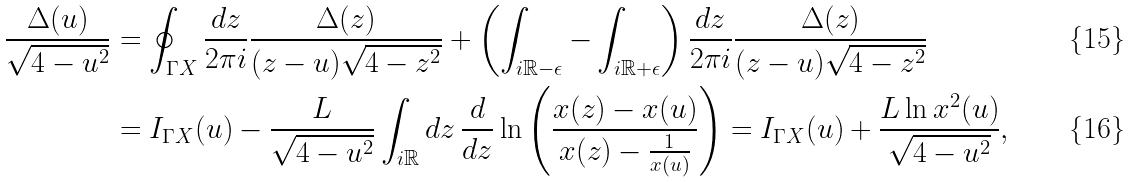<formula> <loc_0><loc_0><loc_500><loc_500>\frac { \Delta ( u ) } { \sqrt { 4 - u ^ { 2 } } } & = \oint _ { \Gamma X } \frac { d z } { 2 \pi i } \frac { \Delta ( z ) } { ( z - u ) \sqrt { 4 - z ^ { 2 } } } + \left ( \int _ { i \mathbb { R } - \epsilon } - \int _ { i \mathbb { R } + \epsilon } \right ) \frac { d z } { 2 \pi i } \frac { \Delta ( z ) } { ( z - u ) \sqrt { 4 - z ^ { 2 } } } \\ & = I _ { \Gamma X } ( u ) - \frac { L } { \sqrt { 4 - u ^ { 2 } } } \int _ { i \mathbb { R } } d z \, \frac { d } { d z } \ln \left ( \frac { x ( z ) - x ( u ) } { x ( z ) - \frac { 1 } { x ( u ) } } \right ) = I _ { \Gamma X } ( u ) + \frac { L \ln { x ^ { 2 } ( u ) } } { \sqrt { 4 - u ^ { 2 } } } ,</formula> 